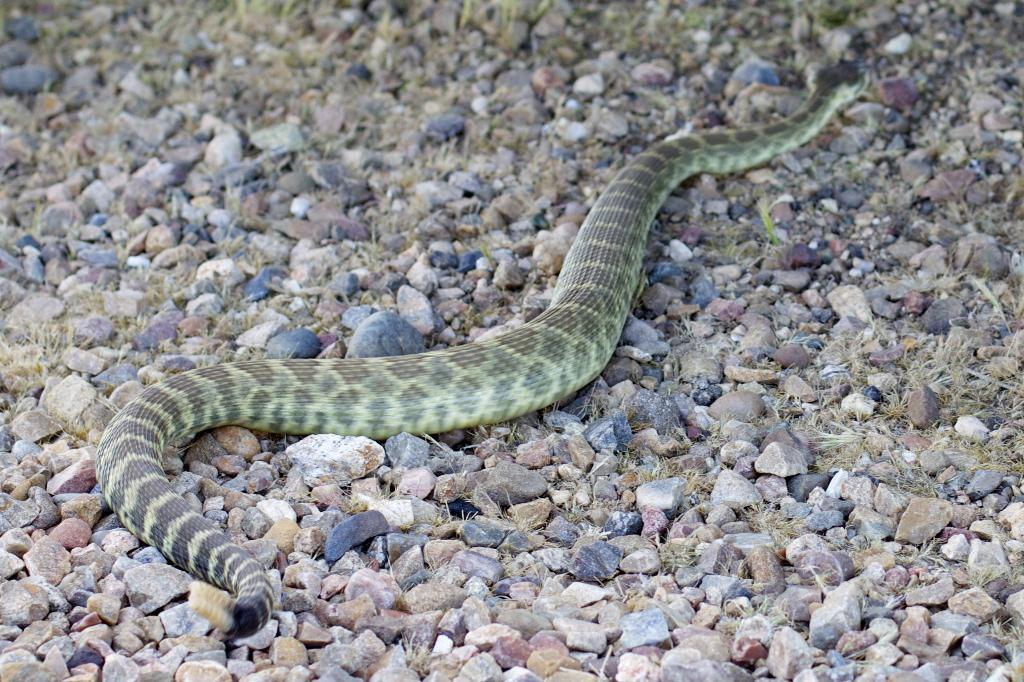What animal is present in the picture? There is a snake in the picture. Where is the snake located? The snake is on the ground. What type of terrain can be seen in the picture? There are stones and grass visible in the picture. What type of government is depicted in the picture? There is no depiction of a government in the picture; it features a snake on the ground with stones and grass. Is the snake poisonous in the picture? The picture does not provide information about the snake's venomous nature; it only shows the snake's presence on the ground. 